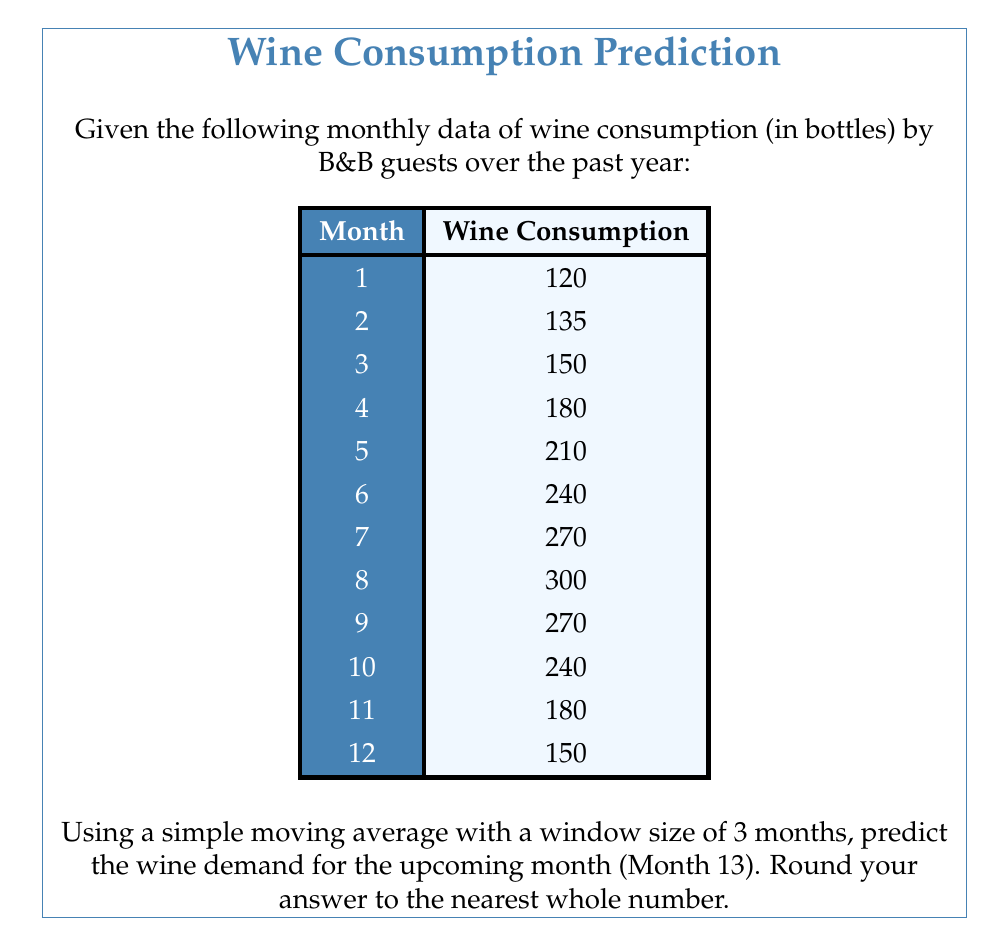Could you help me with this problem? To solve this problem, we'll use a simple moving average (SMA) with a window size of 3 months. The SMA is calculated by taking the average of the most recent 3 months' data.

Steps to solve:

1. Identify the last 3 months' data:
   Month 10: 240 bottles
   Month 11: 180 bottles
   Month 12: 150 bottles

2. Calculate the SMA:
   $$SMA = \frac{240 + 180 + 150}{3} = \frac{570}{3} = 190$$

3. The SMA of 190 bottles is our prediction for Month 13.

This method assumes that the short-term trend will continue, smoothing out some of the fluctuations in the data. It's important to note that this simple method doesn't account for seasonality or long-term trends, which might be present in the wine consumption data for a B&B. For more accurate predictions, more advanced time series analysis techniques like ARIMA or exponential smoothing might be considered.
Answer: 190 bottles 